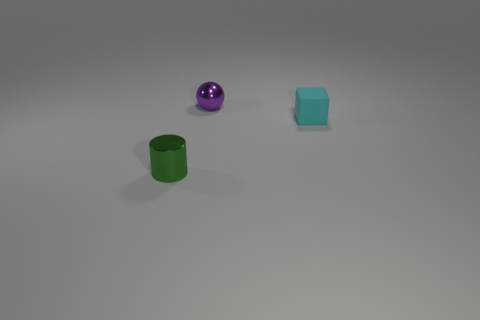Describe the surface on which the objects are placed. The objects are placed on a smooth, matte finish surface that is light grey in color. The surface is flat and even, which emphasizes the objects’ shadows and their individual colors. 